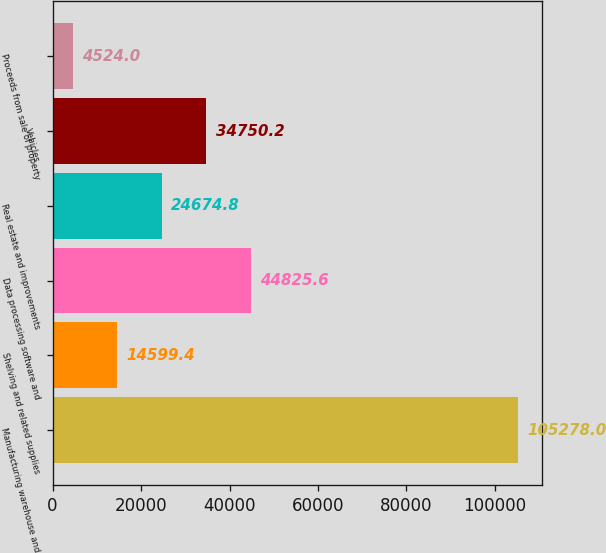Convert chart. <chart><loc_0><loc_0><loc_500><loc_500><bar_chart><fcel>Manufacturing warehouse and<fcel>Shelving and related supplies<fcel>Data processing software and<fcel>Real estate and improvements<fcel>Vehicles<fcel>Proceeds from sale of property<nl><fcel>105278<fcel>14599.4<fcel>44825.6<fcel>24674.8<fcel>34750.2<fcel>4524<nl></chart> 